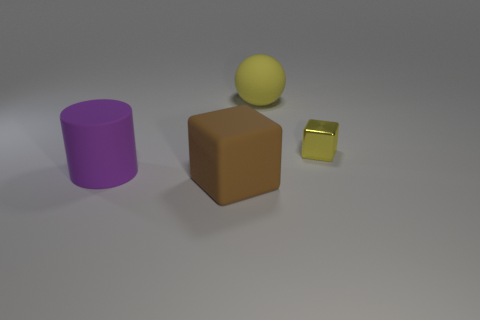Add 2 big rubber objects. How many objects exist? 6 Subtract all spheres. How many objects are left? 3 Subtract all big rubber objects. Subtract all small red shiny things. How many objects are left? 1 Add 4 small yellow cubes. How many small yellow cubes are left? 5 Add 4 gray rubber cylinders. How many gray rubber cylinders exist? 4 Subtract 0 cyan spheres. How many objects are left? 4 